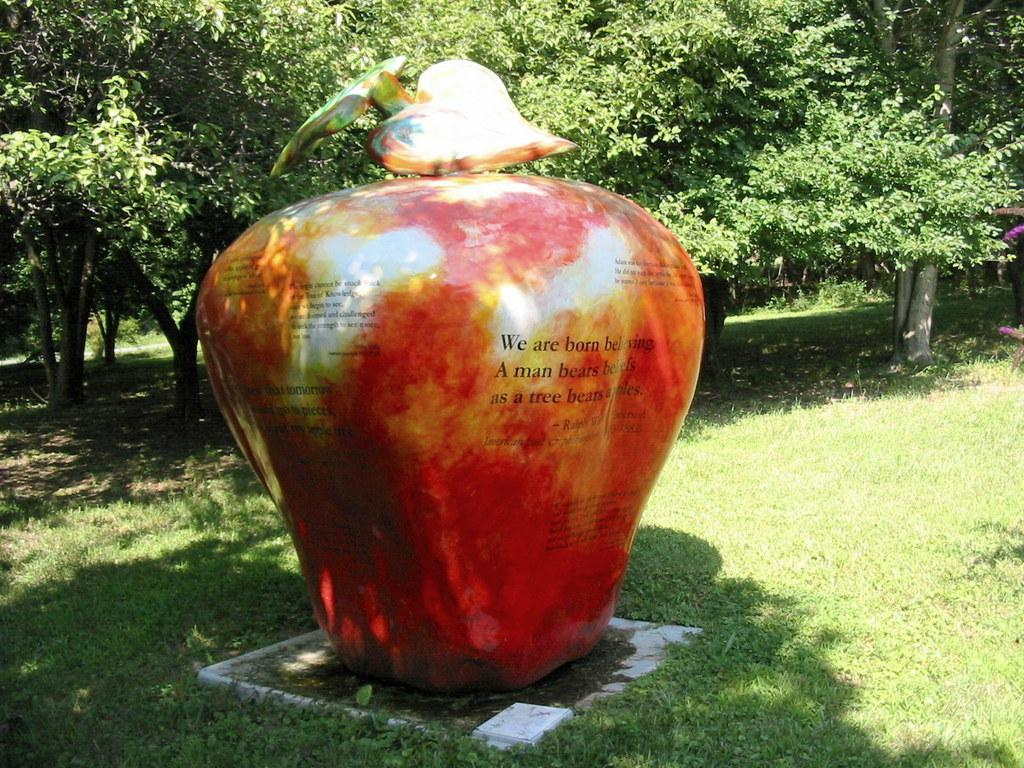What is the main subject of the image? There is a statue of an apple in the image. What is written on the statue? The statue has some paragraphs on it. What type of vegetation is visible in the image? There is grass visible in the image. What can be seen in the background of the image? There are trees in the background of the image. What decision does the apple make in the image? There is no decision-making process depicted in the image, as it features a statue of an apple with paragraphs on it. What type of ray is emitted from the apple in the image? There is no ray emitted from the apple in the image; it is a statue with paragraphs on it. 